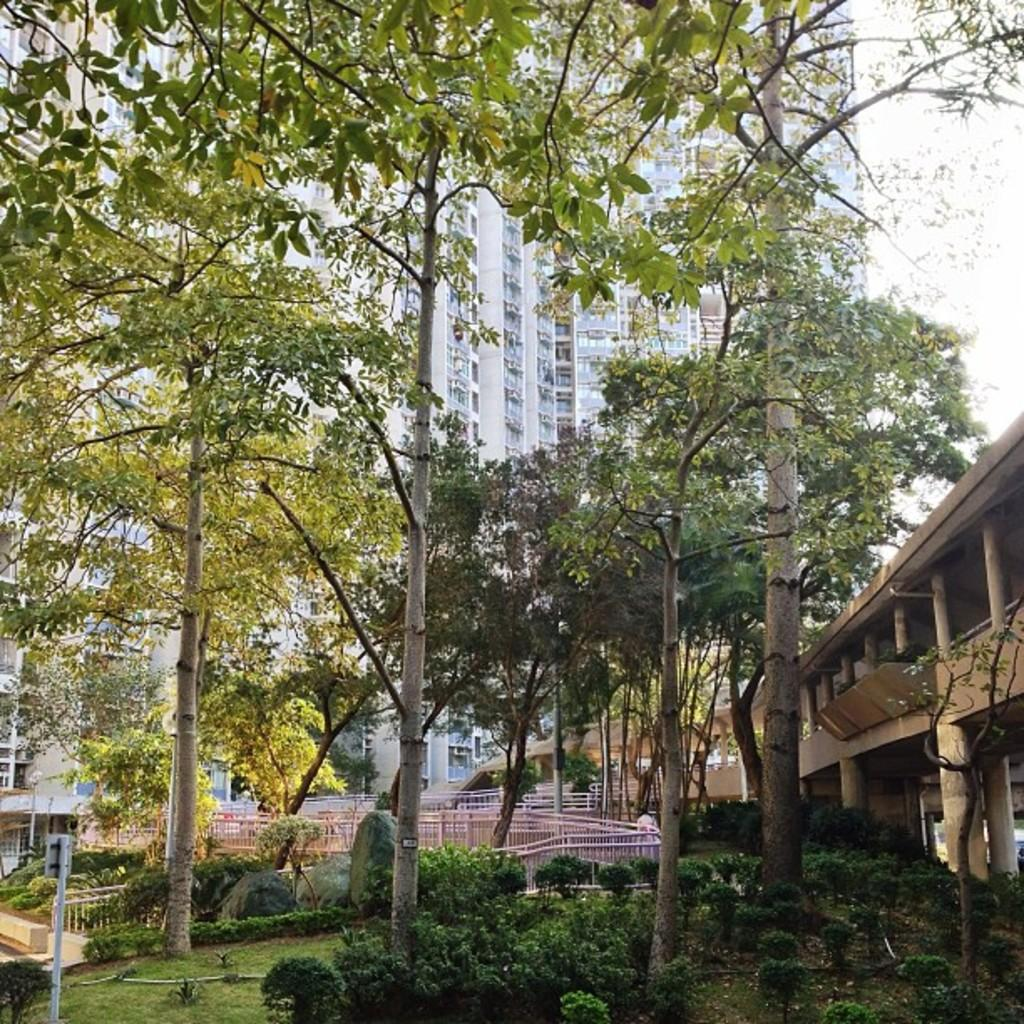What type of location is shown in the image? The image depicts a garden. What can be seen in the garden besides plants? There are tall trees in the garden. What other types of vegetation are present in the garden? There are plants in the garden. What is visible behind the garden? There is a huge building behind the garden. What type of error can be seen in the image? There is no error present in the image; it depicts a garden with tall trees, plants, and a huge building in the background. What does the garden smell like in the image? The image does not provide information about the scent of the garden, so it cannot be determined from the image. 